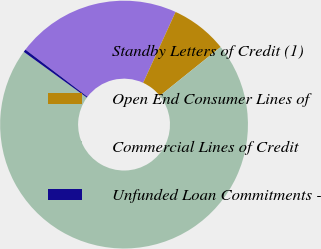Convert chart to OTSL. <chart><loc_0><loc_0><loc_500><loc_500><pie_chart><fcel>Standby Letters of Credit (1)<fcel>Open End Consumer Lines of<fcel>Commercial Lines of Credit<fcel>Unfunded Loan Commitments -<nl><fcel>21.48%<fcel>7.4%<fcel>70.76%<fcel>0.36%<nl></chart> 